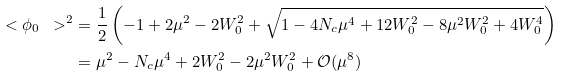Convert formula to latex. <formula><loc_0><loc_0><loc_500><loc_500>\ < \phi _ { 0 } \ > ^ { 2 } & = \frac { 1 } { 2 } \left ( - 1 + 2 \mu ^ { 2 } - 2 W _ { 0 } ^ { 2 } + \sqrt { 1 - 4 N _ { c } \mu ^ { 4 } + 1 2 W _ { 0 } ^ { 2 } - 8 \mu ^ { 2 } W _ { 0 } ^ { 2 } + 4 W _ { 0 } ^ { 4 } } \right ) \\ & = \mu ^ { 2 } - N _ { c } \mu ^ { 4 } + 2 W _ { 0 } ^ { 2 } - 2 \mu ^ { 2 } W _ { 0 } ^ { 2 } + \mathcal { O } ( \mu ^ { 8 } )</formula> 